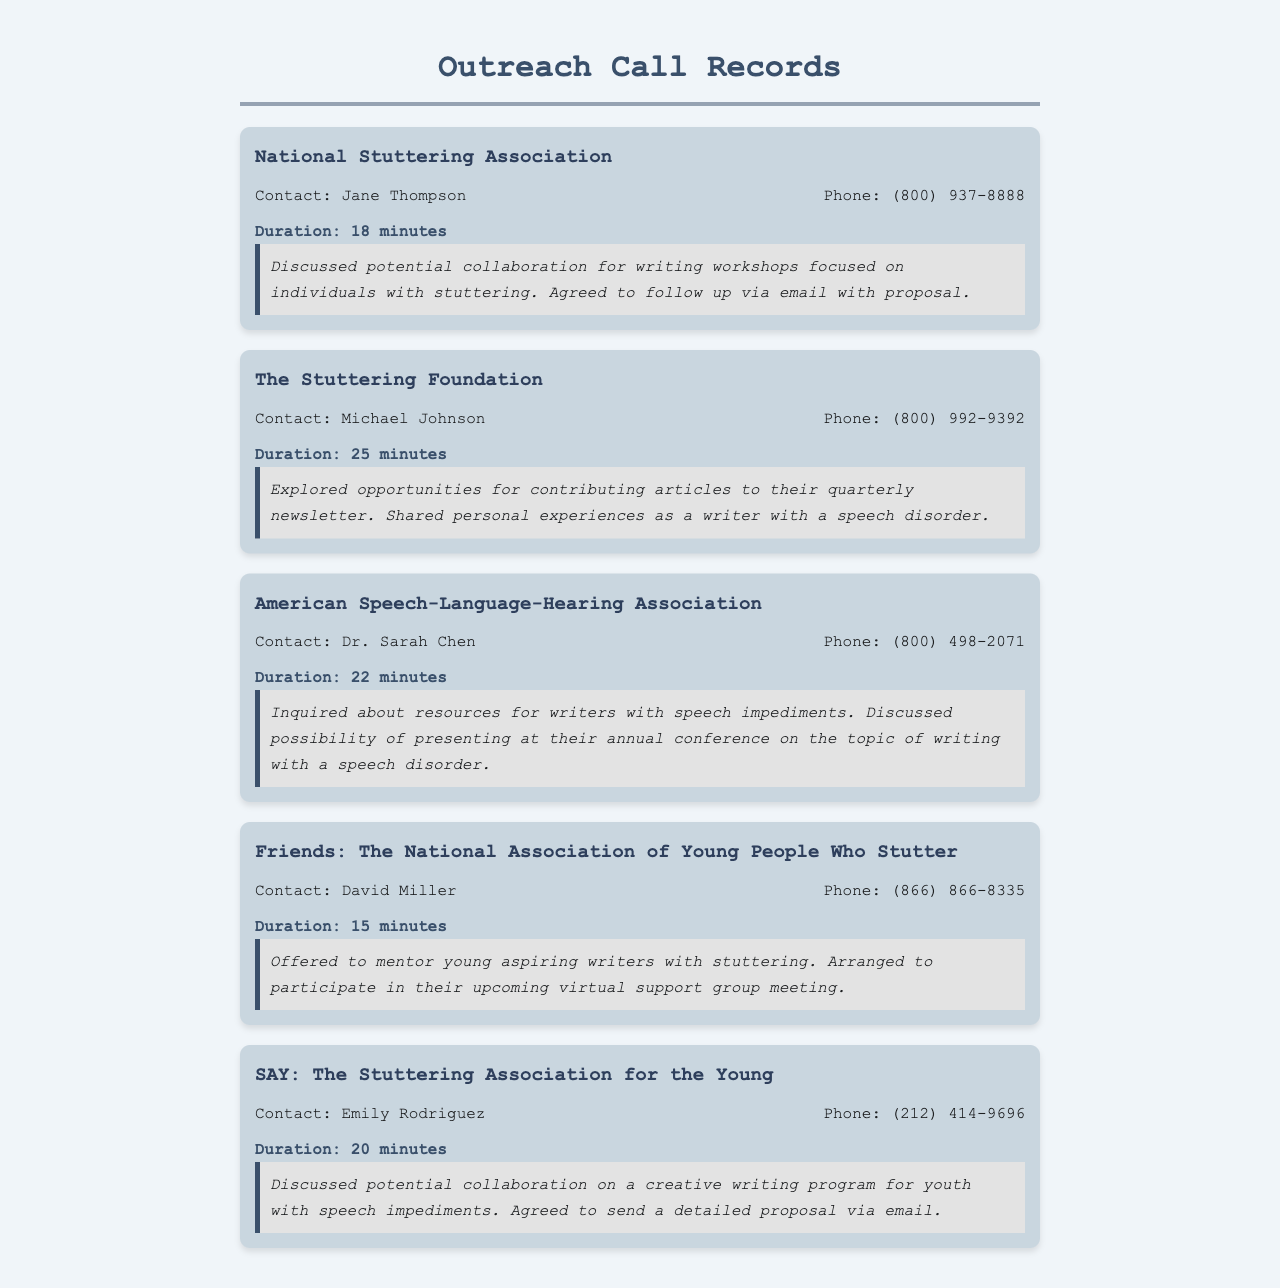what organization was contacted for collaboration on writing workshops? The organization discussed for collaboration on writing workshops was the National Stuttering Association.
Answer: National Stuttering Association who was the contact person for The Stuttering Foundation? The contact person for The Stuttering Foundation is Michael Johnson.
Answer: Michael Johnson how long was the call with Dr. Sarah Chen? The call duration with Dr. Sarah Chen was mentioned in the record.
Answer: 22 minutes which organization offered to mentor young aspiring writers? The organization that offered to mentor young aspiring writers is Friends: The National Association of Young People Who Stutter.
Answer: Friends: The National Association of Young People Who Stutter what was the main topic of discussion during the call with SAY? The main topic discussed during the call with SAY was a creative writing program for youth with speech impediments.
Answer: creative writing program how many organizations were contacted in total? The document lists several organizations contacted for outreach calls.
Answer: Five what follow-up action was agreed upon with the National Stuttering Association? The follow-up action agreed upon was to send a proposal via email.
Answer: follow up via email with proposal what did the call with American Speech-Language-Hearing Association inquire about? The call inquired about resources for writers with speech impediments and presented possible speaking opportunities.
Answer: resources for writers who is the contact at SAY? The contact person at SAY mentioned in the document is Emily Rodriguez.
Answer: Emily Rodriguez 